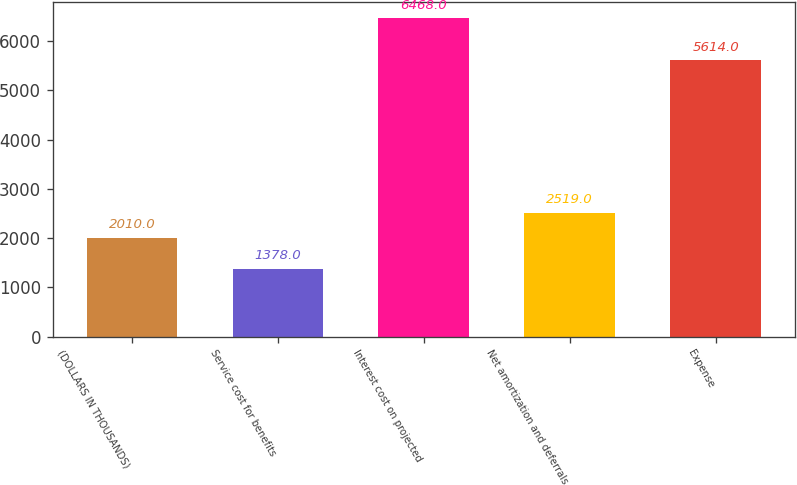Convert chart. <chart><loc_0><loc_0><loc_500><loc_500><bar_chart><fcel>(DOLLARS IN THOUSANDS)<fcel>Service cost for benefits<fcel>Interest cost on projected<fcel>Net amortization and deferrals<fcel>Expense<nl><fcel>2010<fcel>1378<fcel>6468<fcel>2519<fcel>5614<nl></chart> 